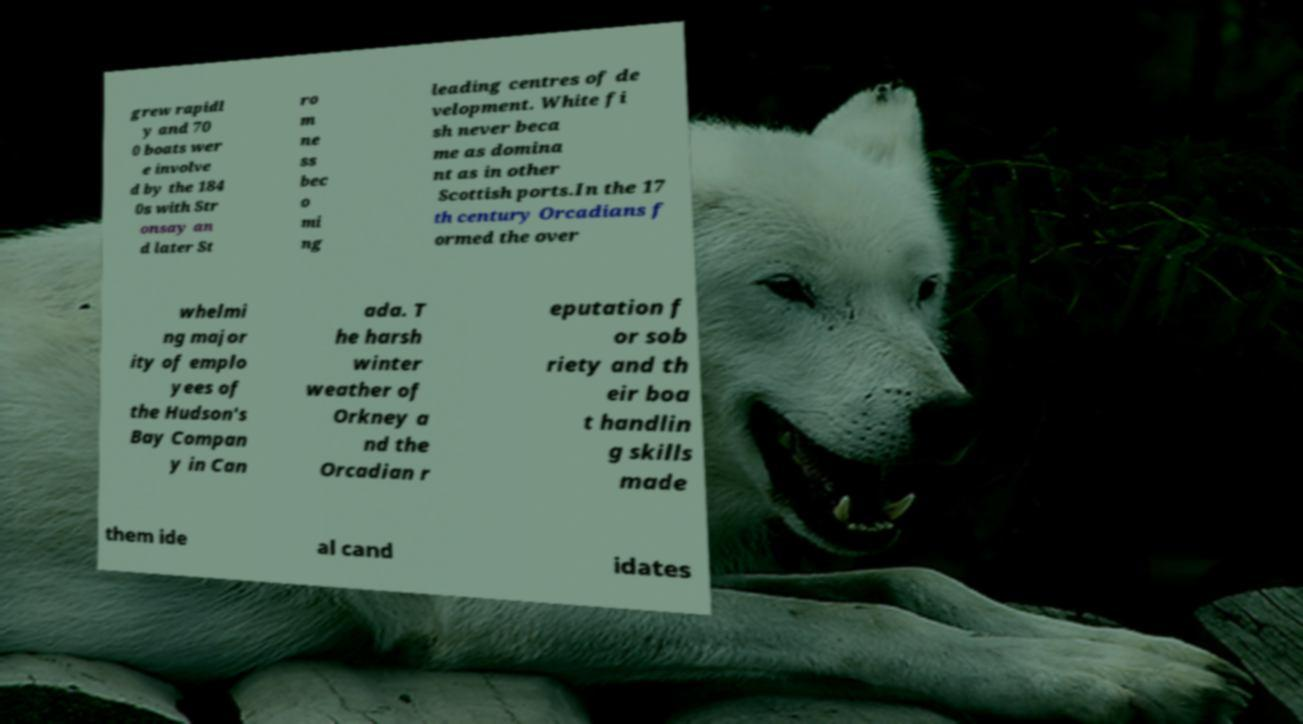Could you extract and type out the text from this image? grew rapidl y and 70 0 boats wer e involve d by the 184 0s with Str onsay an d later St ro m ne ss bec o mi ng leading centres of de velopment. White fi sh never beca me as domina nt as in other Scottish ports.In the 17 th century Orcadians f ormed the over whelmi ng major ity of emplo yees of the Hudson's Bay Compan y in Can ada. T he harsh winter weather of Orkney a nd the Orcadian r eputation f or sob riety and th eir boa t handlin g skills made them ide al cand idates 